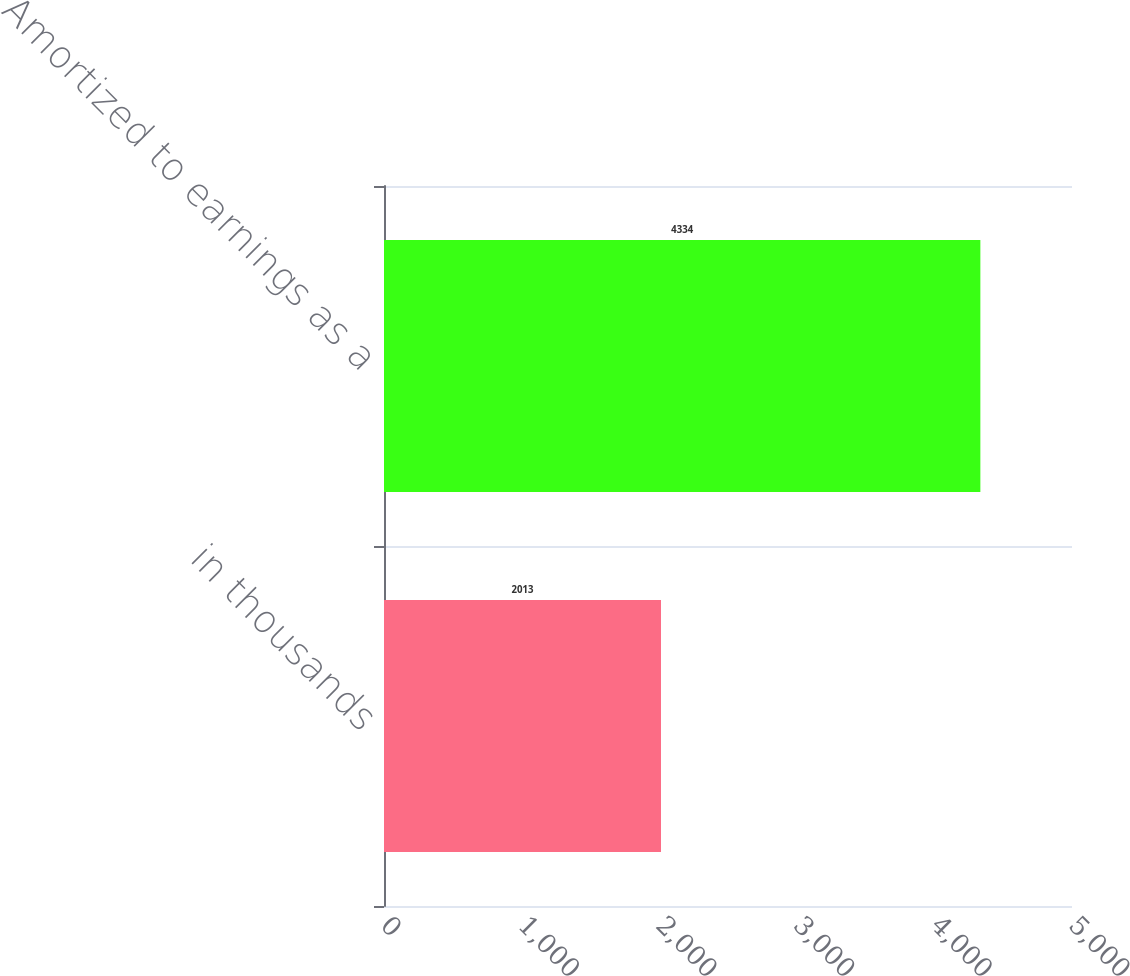Convert chart to OTSL. <chart><loc_0><loc_0><loc_500><loc_500><bar_chart><fcel>in thousands<fcel>Amortized to earnings as a<nl><fcel>2013<fcel>4334<nl></chart> 